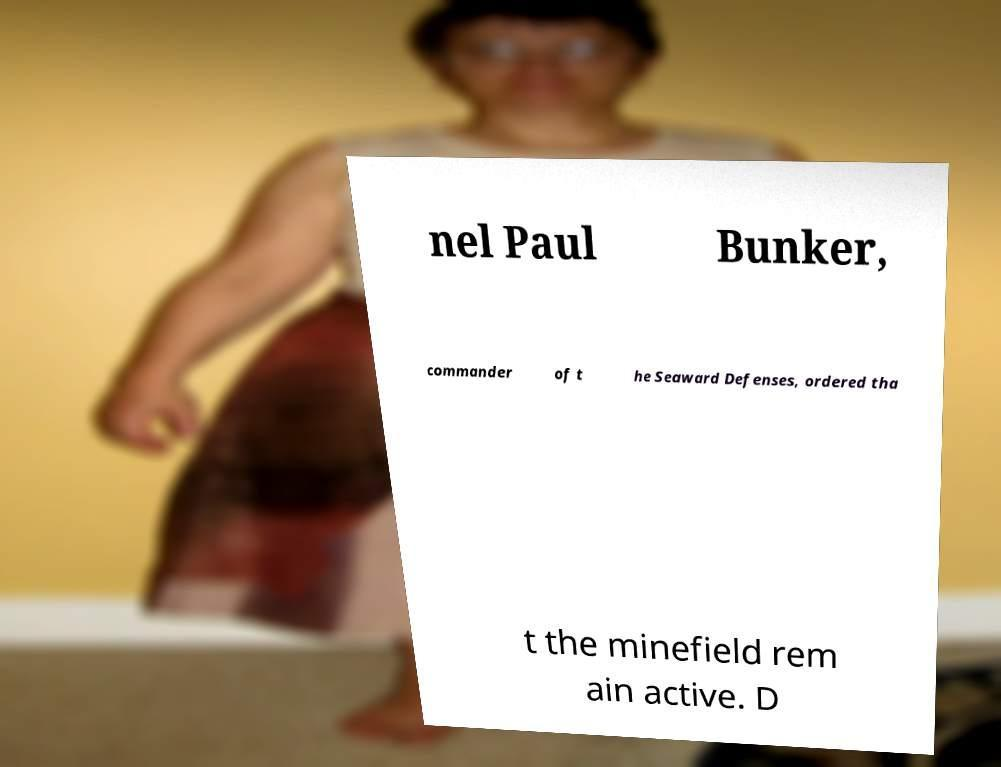Can you accurately transcribe the text from the provided image for me? nel Paul Bunker, commander of t he Seaward Defenses, ordered tha t the minefield rem ain active. D 